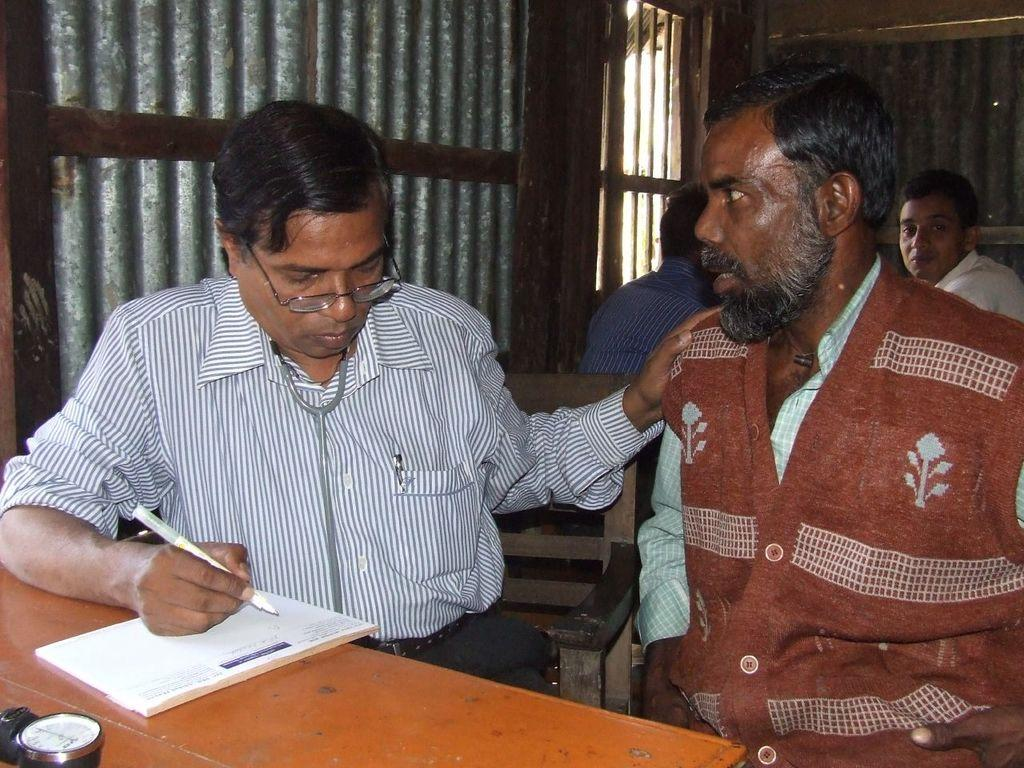What is the profession of the person in the image? There is a doctor in the image. What is the doctor doing in the image? The doctor is writing a prescription and asking questions to a patient. What is the patient doing in the image? The patient is discussing his symptoms. Are there any other people present in the image? Yes, there are two men sitting behind the doctor and patient. What type of country is being served for lunch in the image? There is no mention of lunch or any country's cuisine in the image. The image depicts a doctor interacting with a patient and two other men. 